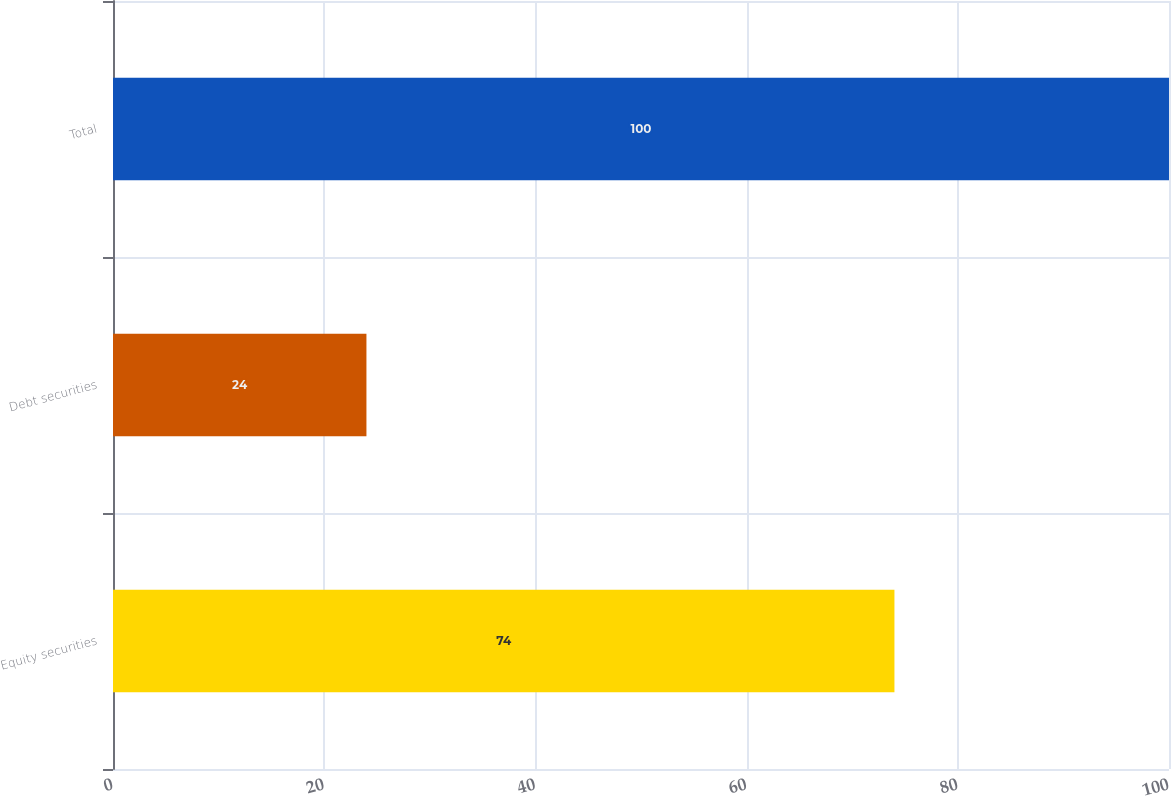<chart> <loc_0><loc_0><loc_500><loc_500><bar_chart><fcel>Equity securities<fcel>Debt securities<fcel>Total<nl><fcel>74<fcel>24<fcel>100<nl></chart> 